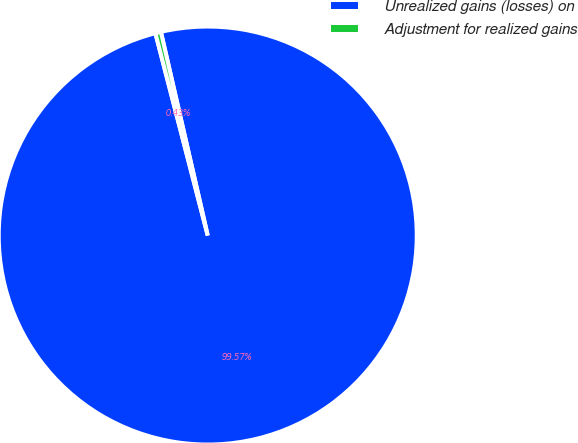<chart> <loc_0><loc_0><loc_500><loc_500><pie_chart><fcel>Unrealized gains (losses) on<fcel>Adjustment for realized gains<nl><fcel>99.57%<fcel>0.43%<nl></chart> 